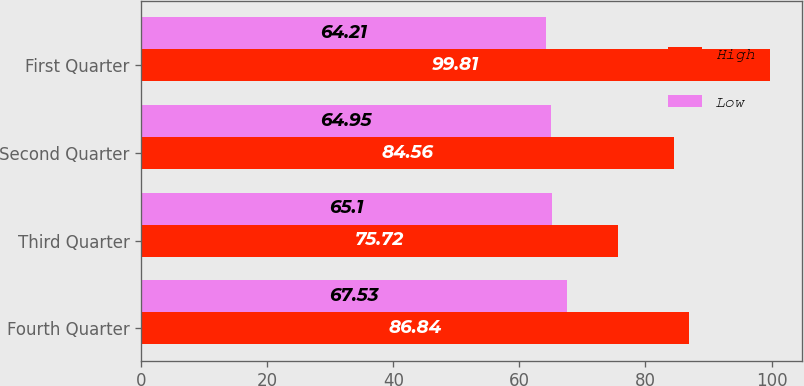<chart> <loc_0><loc_0><loc_500><loc_500><stacked_bar_chart><ecel><fcel>Fourth Quarter<fcel>Third Quarter<fcel>Second Quarter<fcel>First Quarter<nl><fcel>High<fcel>86.84<fcel>75.72<fcel>84.56<fcel>99.81<nl><fcel>Low<fcel>67.53<fcel>65.1<fcel>64.95<fcel>64.21<nl></chart> 